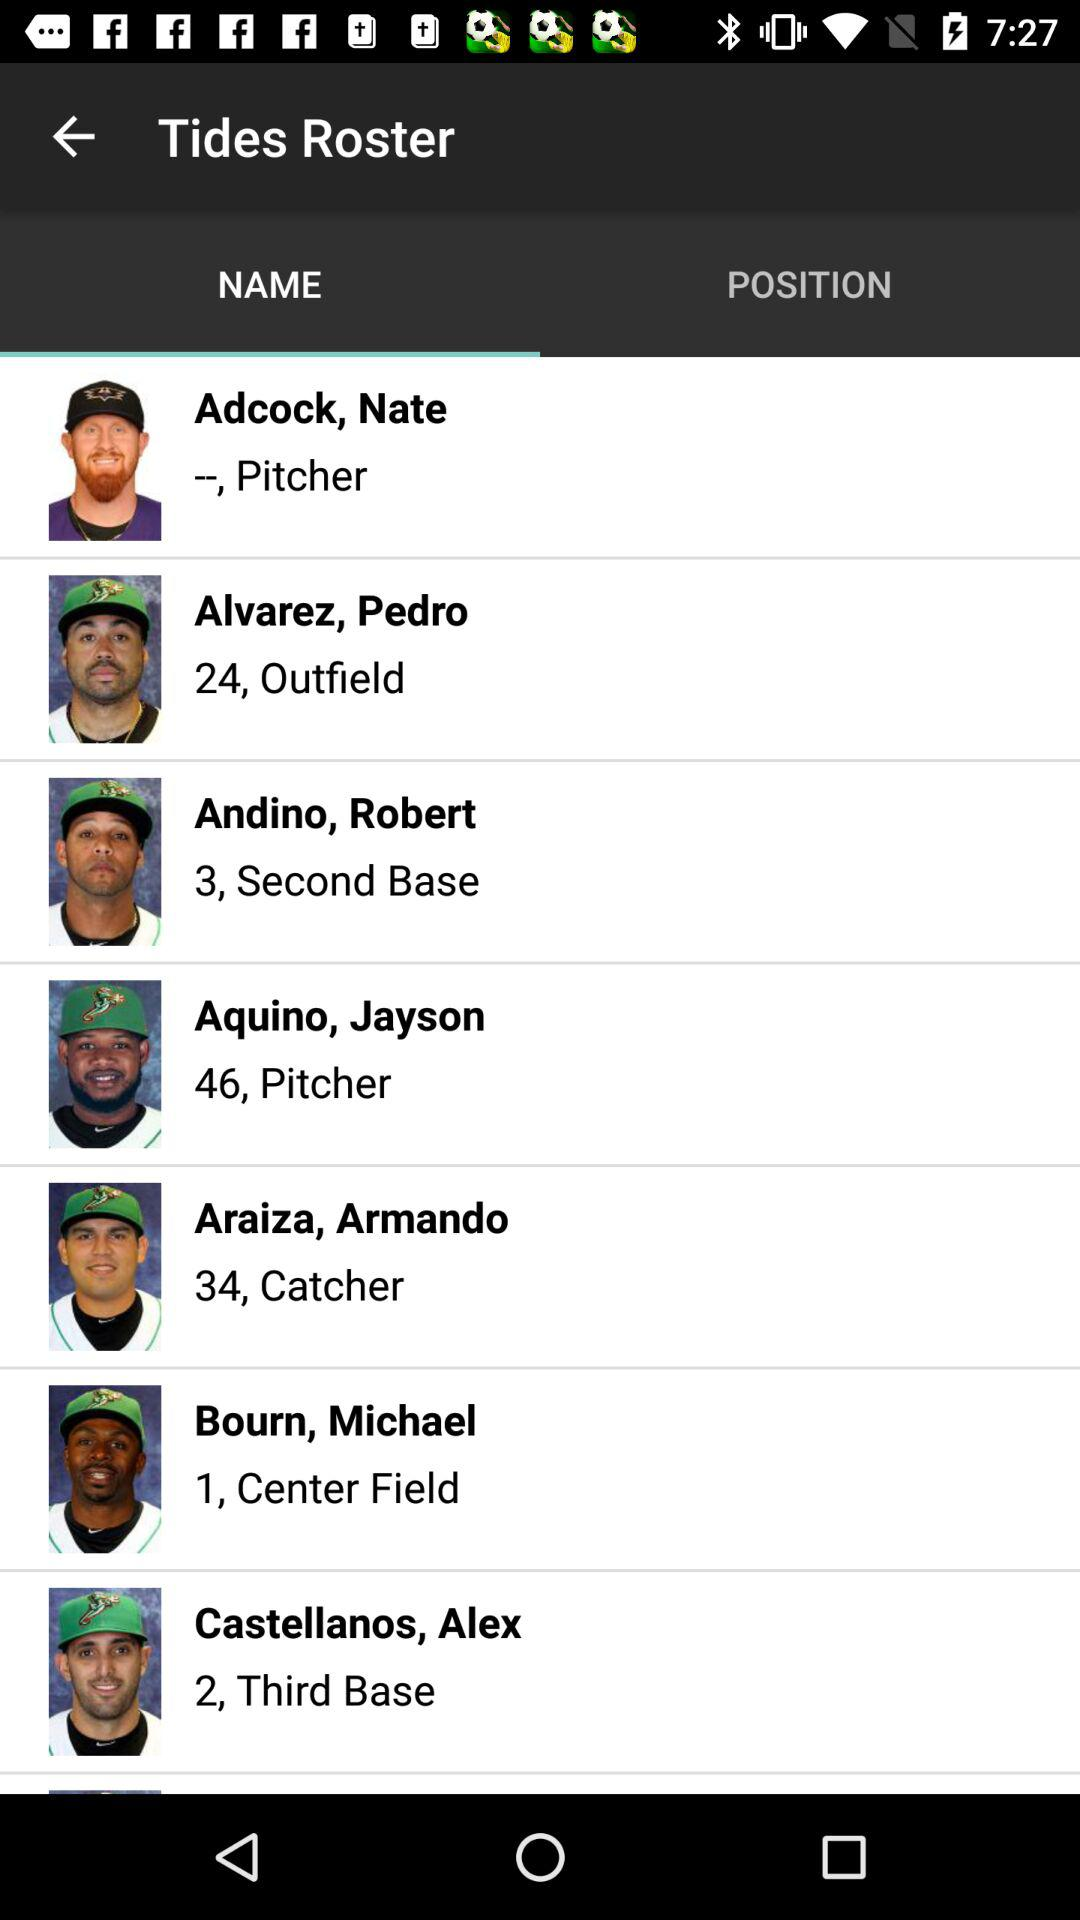Who is aligned in the center field? The center field is assigned to Michael Bourn. 